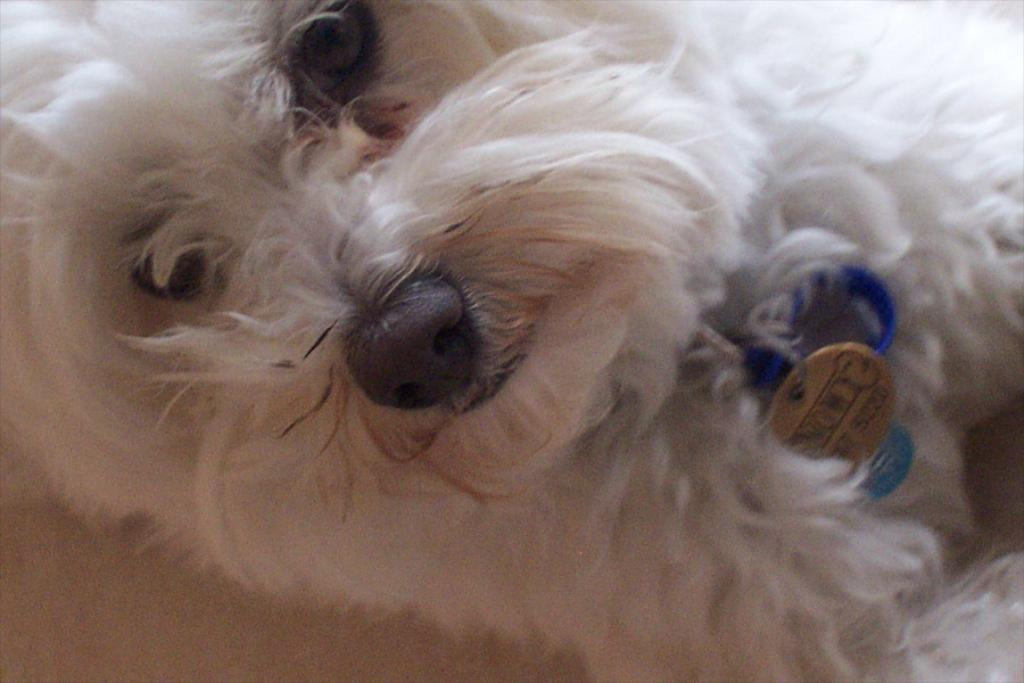What type of animal is present in the image? There is a dog in the image. What type of arch can be seen in the background of the image? There is no arch present in the image; it only features a dog. 